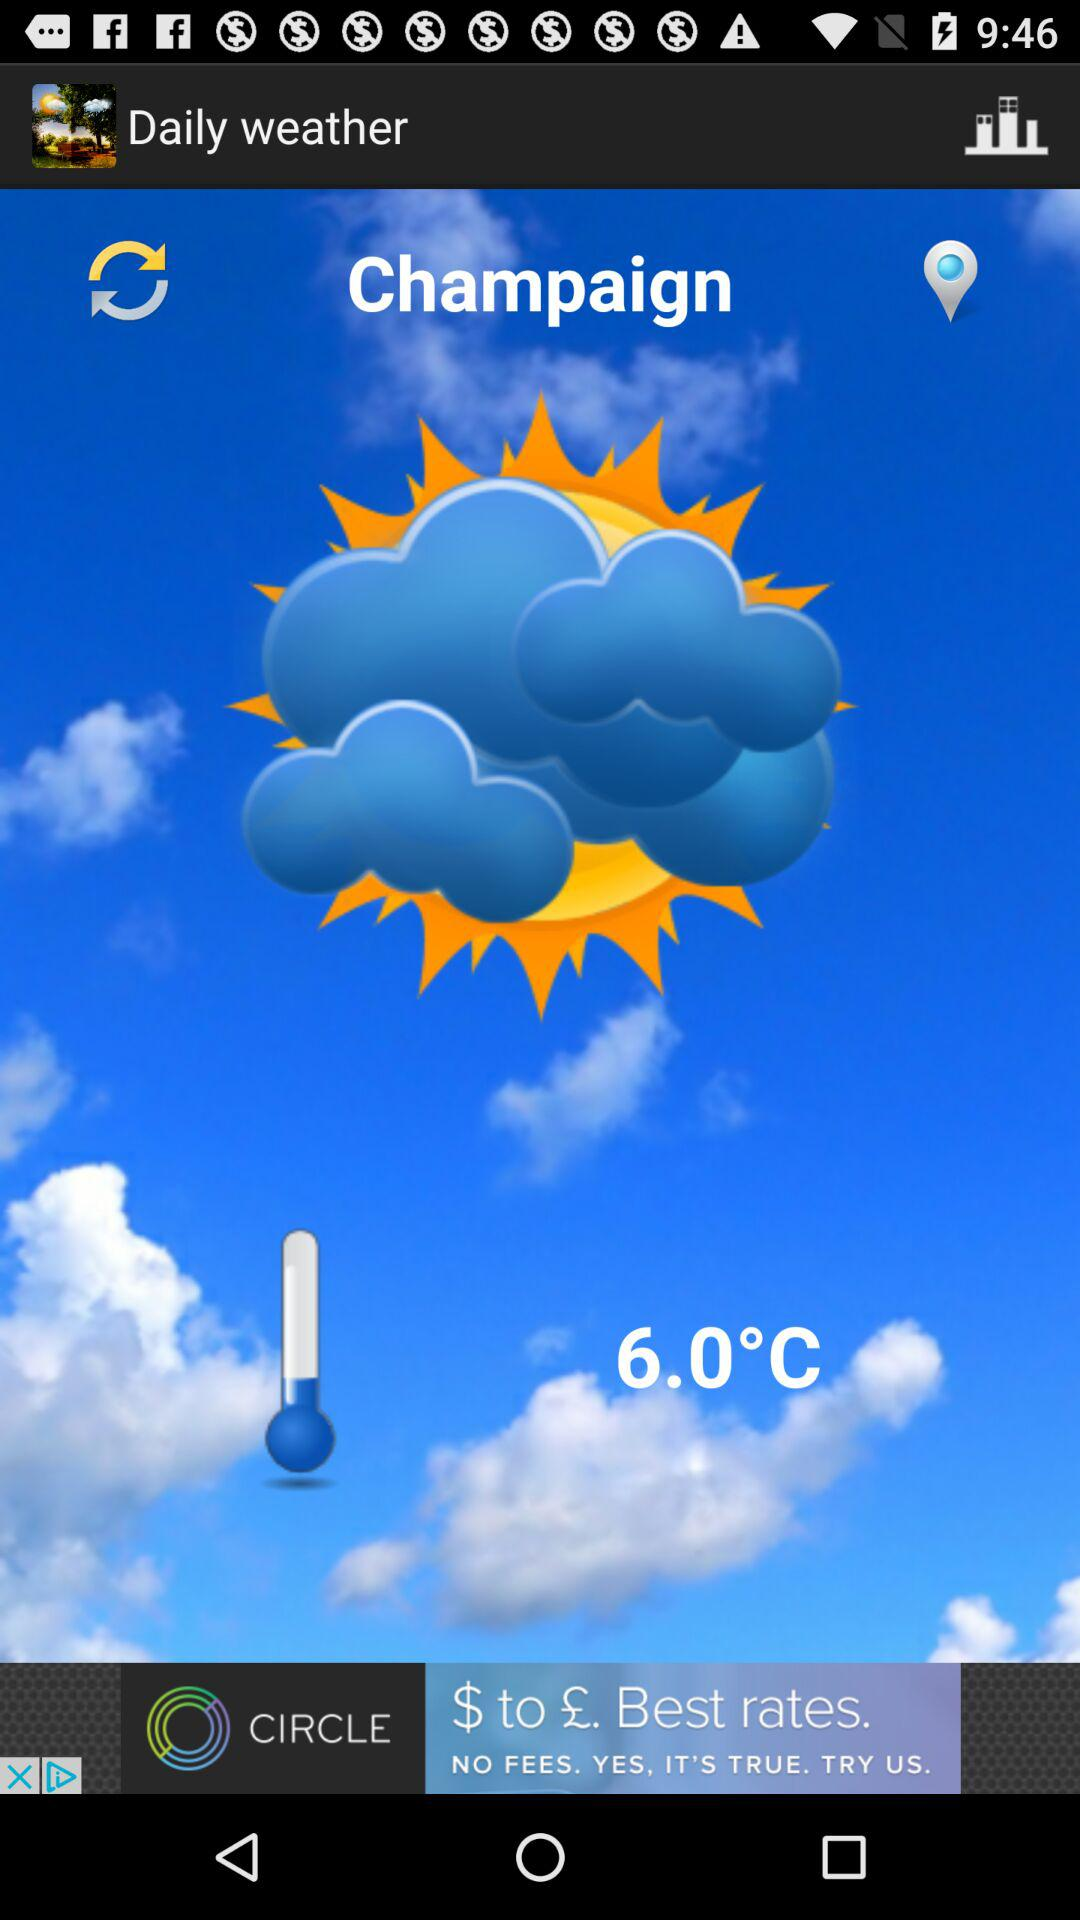What is the name of the application? The name of the application is "Daily weather". 